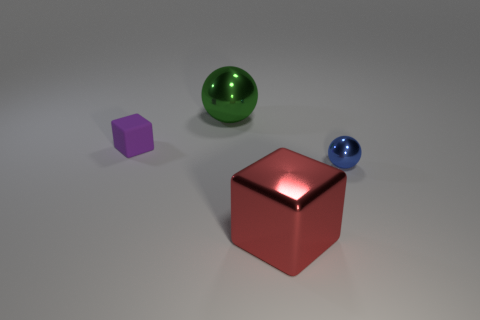How big is the thing that is on the right side of the red thing?
Your answer should be very brief. Small. There is a big thing that is behind the blue ball; how many metal cubes are to the right of it?
Make the answer very short. 1. Does the object that is behind the small purple block have the same shape as the tiny object to the right of the green sphere?
Provide a short and direct response. Yes. What number of things are both to the right of the small block and behind the small blue sphere?
Your answer should be very brief. 1. There is a blue thing that is the same size as the purple block; what is its shape?
Offer a terse response. Sphere. There is a tiny matte block; are there any things on the right side of it?
Offer a very short reply. Yes. Does the blue ball to the right of the red thing have the same material as the cube that is behind the large metal cube?
Your answer should be very brief. No. What number of brown cylinders are the same size as the blue metal object?
Give a very brief answer. 0. What material is the tiny object that is left of the red metallic object?
Ensure brevity in your answer.  Rubber. How many small blue things are the same shape as the big green shiny object?
Give a very brief answer. 1. 